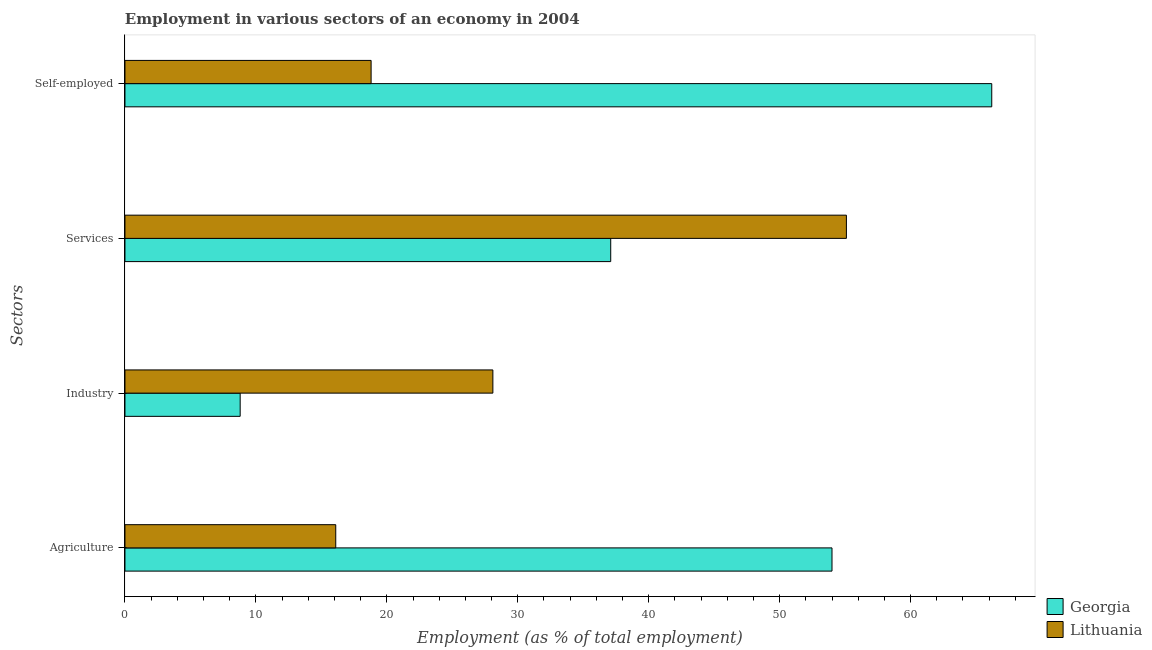How many different coloured bars are there?
Offer a terse response. 2. Are the number of bars on each tick of the Y-axis equal?
Ensure brevity in your answer.  Yes. How many bars are there on the 3rd tick from the top?
Your answer should be compact. 2. How many bars are there on the 2nd tick from the bottom?
Your answer should be compact. 2. What is the label of the 4th group of bars from the top?
Give a very brief answer. Agriculture. What is the percentage of self employed workers in Lithuania?
Provide a succinct answer. 18.8. Across all countries, what is the minimum percentage of workers in agriculture?
Make the answer very short. 16.1. In which country was the percentage of self employed workers maximum?
Your answer should be compact. Georgia. In which country was the percentage of workers in industry minimum?
Keep it short and to the point. Georgia. What is the total percentage of self employed workers in the graph?
Offer a terse response. 85. What is the difference between the percentage of self employed workers in Lithuania and that in Georgia?
Offer a terse response. -47.4. What is the difference between the percentage of workers in services in Georgia and the percentage of workers in agriculture in Lithuania?
Ensure brevity in your answer.  21. What is the average percentage of self employed workers per country?
Provide a succinct answer. 42.5. What is the difference between the percentage of workers in industry and percentage of self employed workers in Lithuania?
Your answer should be very brief. 9.3. In how many countries, is the percentage of workers in agriculture greater than 40 %?
Make the answer very short. 1. What is the ratio of the percentage of workers in agriculture in Georgia to that in Lithuania?
Provide a short and direct response. 3.35. Is the percentage of self employed workers in Lithuania less than that in Georgia?
Your response must be concise. Yes. Is the difference between the percentage of self employed workers in Georgia and Lithuania greater than the difference between the percentage of workers in services in Georgia and Lithuania?
Your answer should be very brief. Yes. What is the difference between the highest and the second highest percentage of workers in agriculture?
Provide a succinct answer. 37.9. What is the difference between the highest and the lowest percentage of workers in services?
Your answer should be very brief. 18. Is it the case that in every country, the sum of the percentage of workers in services and percentage of workers in agriculture is greater than the sum of percentage of self employed workers and percentage of workers in industry?
Ensure brevity in your answer.  No. What does the 2nd bar from the top in Agriculture represents?
Provide a short and direct response. Georgia. What does the 2nd bar from the bottom in Services represents?
Ensure brevity in your answer.  Lithuania. Is it the case that in every country, the sum of the percentage of workers in agriculture and percentage of workers in industry is greater than the percentage of workers in services?
Your answer should be compact. No. How many bars are there?
Offer a terse response. 8. Are all the bars in the graph horizontal?
Offer a terse response. Yes. How many countries are there in the graph?
Keep it short and to the point. 2. Are the values on the major ticks of X-axis written in scientific E-notation?
Your answer should be compact. No. Where does the legend appear in the graph?
Make the answer very short. Bottom right. How many legend labels are there?
Provide a succinct answer. 2. How are the legend labels stacked?
Your response must be concise. Vertical. What is the title of the graph?
Your answer should be very brief. Employment in various sectors of an economy in 2004. What is the label or title of the X-axis?
Your answer should be very brief. Employment (as % of total employment). What is the label or title of the Y-axis?
Your response must be concise. Sectors. What is the Employment (as % of total employment) of Lithuania in Agriculture?
Provide a succinct answer. 16.1. What is the Employment (as % of total employment) in Georgia in Industry?
Keep it short and to the point. 8.8. What is the Employment (as % of total employment) of Lithuania in Industry?
Your answer should be compact. 28.1. What is the Employment (as % of total employment) in Georgia in Services?
Make the answer very short. 37.1. What is the Employment (as % of total employment) in Lithuania in Services?
Your answer should be compact. 55.1. What is the Employment (as % of total employment) in Georgia in Self-employed?
Provide a short and direct response. 66.2. What is the Employment (as % of total employment) in Lithuania in Self-employed?
Make the answer very short. 18.8. Across all Sectors, what is the maximum Employment (as % of total employment) in Georgia?
Give a very brief answer. 66.2. Across all Sectors, what is the maximum Employment (as % of total employment) in Lithuania?
Your answer should be compact. 55.1. Across all Sectors, what is the minimum Employment (as % of total employment) in Georgia?
Offer a very short reply. 8.8. Across all Sectors, what is the minimum Employment (as % of total employment) of Lithuania?
Provide a short and direct response. 16.1. What is the total Employment (as % of total employment) in Georgia in the graph?
Your answer should be very brief. 166.1. What is the total Employment (as % of total employment) of Lithuania in the graph?
Your answer should be very brief. 118.1. What is the difference between the Employment (as % of total employment) in Georgia in Agriculture and that in Industry?
Provide a succinct answer. 45.2. What is the difference between the Employment (as % of total employment) of Lithuania in Agriculture and that in Industry?
Offer a very short reply. -12. What is the difference between the Employment (as % of total employment) in Lithuania in Agriculture and that in Services?
Offer a terse response. -39. What is the difference between the Employment (as % of total employment) in Georgia in Agriculture and that in Self-employed?
Offer a very short reply. -12.2. What is the difference between the Employment (as % of total employment) of Georgia in Industry and that in Services?
Offer a terse response. -28.3. What is the difference between the Employment (as % of total employment) in Lithuania in Industry and that in Services?
Give a very brief answer. -27. What is the difference between the Employment (as % of total employment) of Georgia in Industry and that in Self-employed?
Your answer should be compact. -57.4. What is the difference between the Employment (as % of total employment) of Lithuania in Industry and that in Self-employed?
Provide a short and direct response. 9.3. What is the difference between the Employment (as % of total employment) of Georgia in Services and that in Self-employed?
Your answer should be compact. -29.1. What is the difference between the Employment (as % of total employment) of Lithuania in Services and that in Self-employed?
Your answer should be compact. 36.3. What is the difference between the Employment (as % of total employment) in Georgia in Agriculture and the Employment (as % of total employment) in Lithuania in Industry?
Your answer should be compact. 25.9. What is the difference between the Employment (as % of total employment) of Georgia in Agriculture and the Employment (as % of total employment) of Lithuania in Self-employed?
Keep it short and to the point. 35.2. What is the difference between the Employment (as % of total employment) in Georgia in Industry and the Employment (as % of total employment) in Lithuania in Services?
Your answer should be very brief. -46.3. What is the average Employment (as % of total employment) in Georgia per Sectors?
Offer a terse response. 41.52. What is the average Employment (as % of total employment) of Lithuania per Sectors?
Make the answer very short. 29.52. What is the difference between the Employment (as % of total employment) in Georgia and Employment (as % of total employment) in Lithuania in Agriculture?
Make the answer very short. 37.9. What is the difference between the Employment (as % of total employment) of Georgia and Employment (as % of total employment) of Lithuania in Industry?
Make the answer very short. -19.3. What is the difference between the Employment (as % of total employment) in Georgia and Employment (as % of total employment) in Lithuania in Services?
Offer a very short reply. -18. What is the difference between the Employment (as % of total employment) of Georgia and Employment (as % of total employment) of Lithuania in Self-employed?
Your answer should be compact. 47.4. What is the ratio of the Employment (as % of total employment) in Georgia in Agriculture to that in Industry?
Make the answer very short. 6.14. What is the ratio of the Employment (as % of total employment) in Lithuania in Agriculture to that in Industry?
Keep it short and to the point. 0.57. What is the ratio of the Employment (as % of total employment) of Georgia in Agriculture to that in Services?
Ensure brevity in your answer.  1.46. What is the ratio of the Employment (as % of total employment) of Lithuania in Agriculture to that in Services?
Your answer should be very brief. 0.29. What is the ratio of the Employment (as % of total employment) of Georgia in Agriculture to that in Self-employed?
Offer a very short reply. 0.82. What is the ratio of the Employment (as % of total employment) in Lithuania in Agriculture to that in Self-employed?
Provide a succinct answer. 0.86. What is the ratio of the Employment (as % of total employment) of Georgia in Industry to that in Services?
Provide a short and direct response. 0.24. What is the ratio of the Employment (as % of total employment) of Lithuania in Industry to that in Services?
Keep it short and to the point. 0.51. What is the ratio of the Employment (as % of total employment) in Georgia in Industry to that in Self-employed?
Give a very brief answer. 0.13. What is the ratio of the Employment (as % of total employment) of Lithuania in Industry to that in Self-employed?
Make the answer very short. 1.49. What is the ratio of the Employment (as % of total employment) of Georgia in Services to that in Self-employed?
Your answer should be compact. 0.56. What is the ratio of the Employment (as % of total employment) in Lithuania in Services to that in Self-employed?
Provide a short and direct response. 2.93. What is the difference between the highest and the second highest Employment (as % of total employment) in Georgia?
Keep it short and to the point. 12.2. What is the difference between the highest and the lowest Employment (as % of total employment) in Georgia?
Keep it short and to the point. 57.4. 